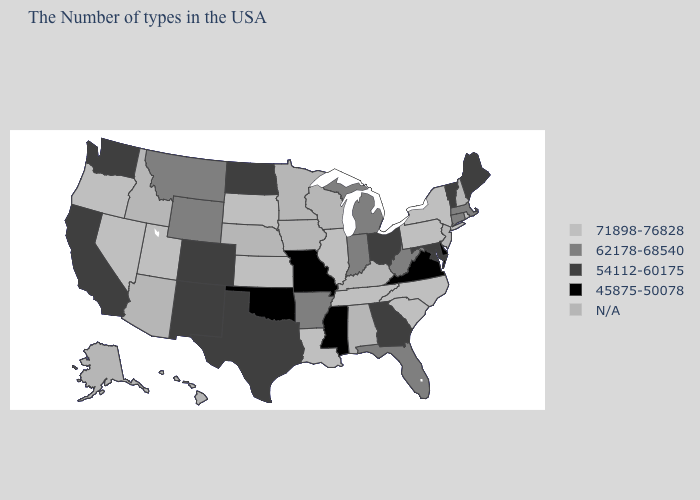Which states hav the highest value in the MidWest?
Write a very short answer. Illinois, Kansas, South Dakota. What is the lowest value in states that border Texas?
Short answer required. 45875-50078. What is the value of West Virginia?
Give a very brief answer. 62178-68540. Among the states that border Connecticut , which have the highest value?
Quick response, please. Rhode Island, New York. Does the map have missing data?
Keep it brief. Yes. Name the states that have a value in the range 62178-68540?
Short answer required. Massachusetts, Connecticut, West Virginia, Florida, Michigan, Indiana, Arkansas, Wyoming, Montana. What is the value of North Dakota?
Answer briefly. 54112-60175. Does Rhode Island have the highest value in the USA?
Answer briefly. Yes. Among the states that border Pennsylvania , does West Virginia have the lowest value?
Be succinct. No. What is the highest value in the USA?
Give a very brief answer. 71898-76828. Is the legend a continuous bar?
Concise answer only. No. Among the states that border Arizona , does Nevada have the lowest value?
Keep it brief. No. Is the legend a continuous bar?
Concise answer only. No. 